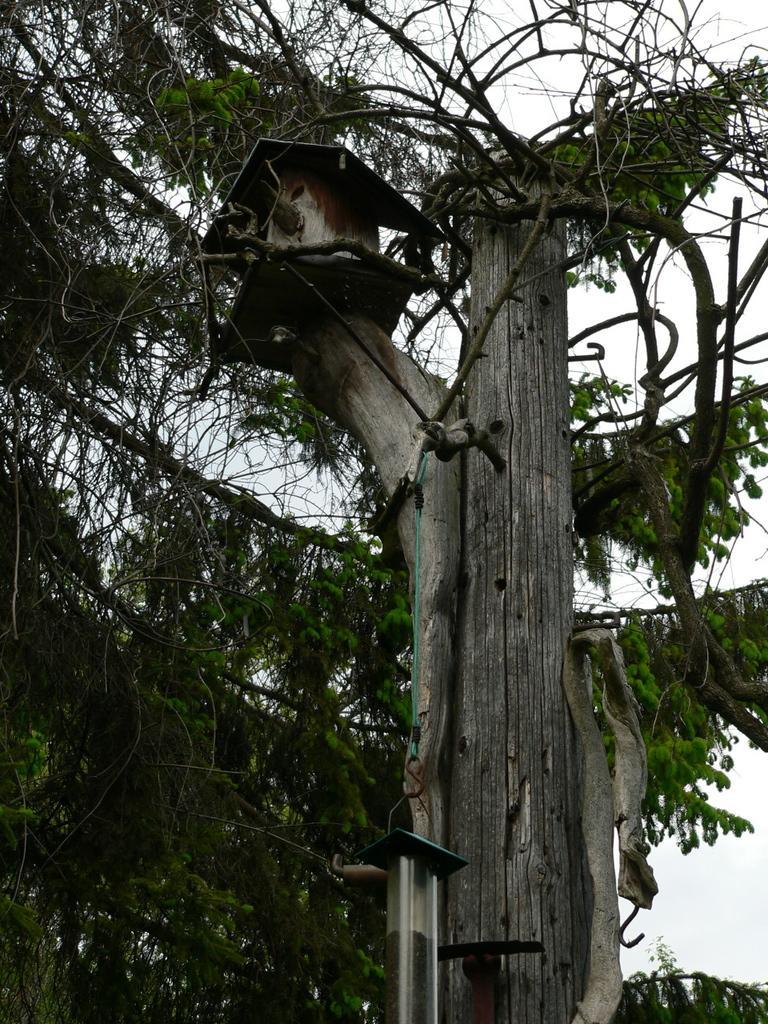Please provide a concise description of this image. In this picture we can see leaves, branches, birdhouse on tree trunk and bird feeder. In the background of the image we can see the sky. 